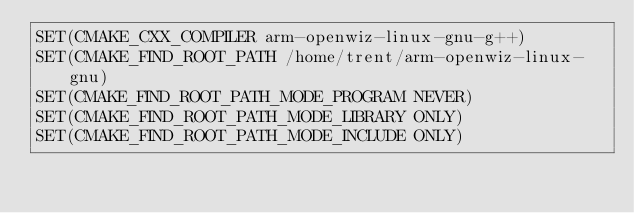Convert code to text. <code><loc_0><loc_0><loc_500><loc_500><_CMake_>SET(CMAKE_CXX_COMPILER arm-openwiz-linux-gnu-g++)
SET(CMAKE_FIND_ROOT_PATH /home/trent/arm-openwiz-linux-gnu)
SET(CMAKE_FIND_ROOT_PATH_MODE_PROGRAM NEVER)
SET(CMAKE_FIND_ROOT_PATH_MODE_LIBRARY ONLY)
SET(CMAKE_FIND_ROOT_PATH_MODE_INCLUDE ONLY)
</code> 